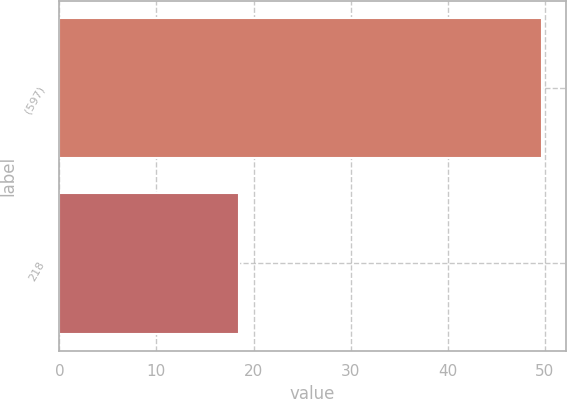Convert chart to OTSL. <chart><loc_0><loc_0><loc_500><loc_500><bar_chart><fcel>(597)<fcel>218<nl><fcel>49.7<fcel>18.5<nl></chart> 